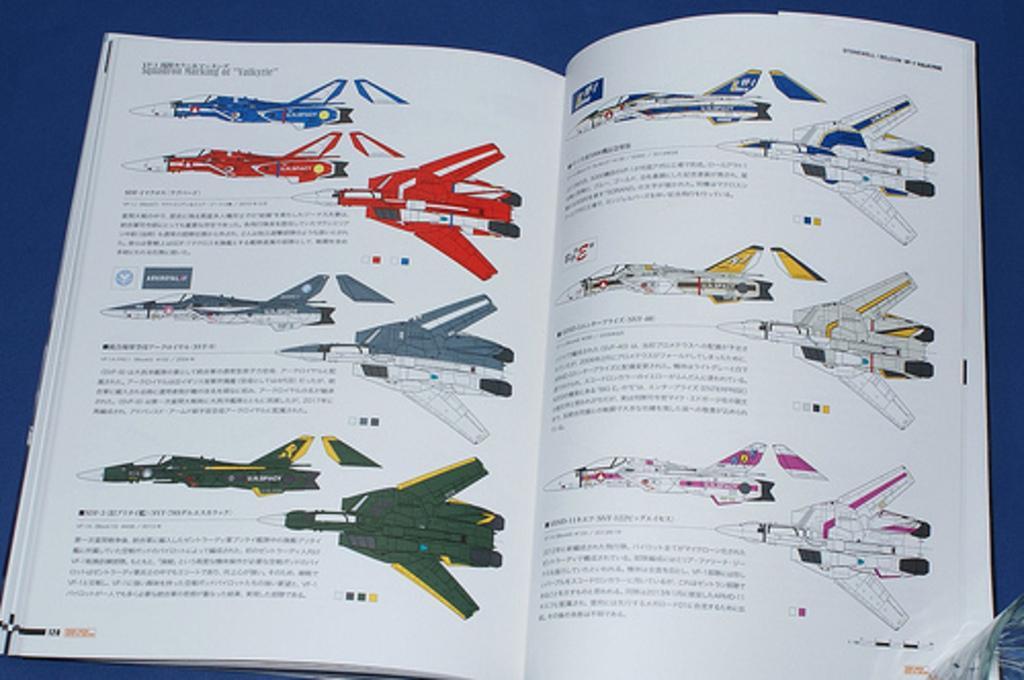How would you summarize this image in a sentence or two? In this picture I can see a book on the table and I can see pictures of few fighter jets and text in the book. 